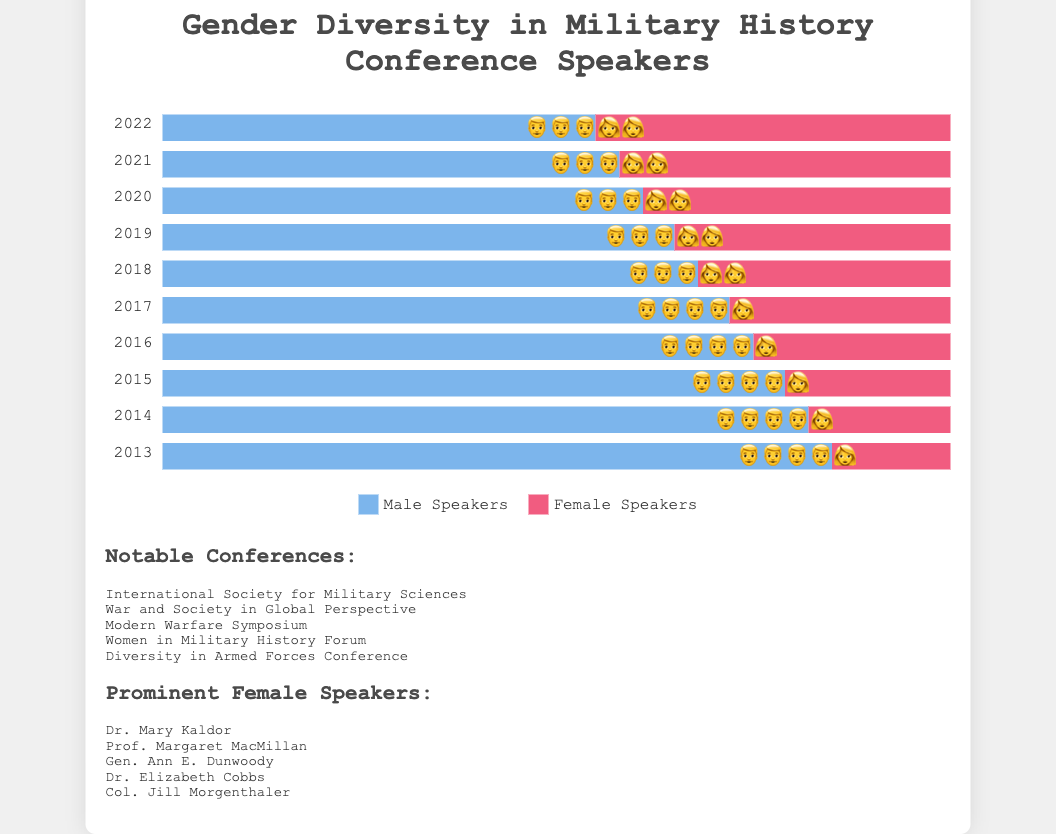What's the general trend in the number of male speakers over the past decade? By examining the bars for male speakers from 2013 to 2022, it's clear that the length of the bars decreases over time, indicating a downward trend. Thus, the number of male speakers has been consistently reducing each year.
Answer: Decreasing trend Which year had the highest percentage of female speakers? By comparing the female speaker bars for each year, 2022 shows the longest bar for female speakers, indicating it had the highest percentage.
Answer: 2022 What is the difference in the number of female speakers between 2013 and 2022? Female speakers in 2022 are 45; in 2013, they are 15. The difference is 45 - 15 = 30.
Answer: 30 Identify the year where male and female speaker percentages are closest. By visually comparing the lengths of both bars year by year, 2022 shows the most similar lengths for male (55%) and female (45%) speakers, indicating the closest percentage.
Answer: 2022 Between which consecutive years was the largest increase in female speakers observed? Observing the increase year by year, the jump from 28% in 2017 to 32% in 2018 (a 4% increase) is the largest.
Answer: Between 2017 and 2018 What percentage of speakers were male in 2015? The bar for male speakers in 2015 occupies 79% of the space, indicating 79% of the speakers were male.
Answer: 79% Compare the number of female speakers in 2016 and 2019. Which year had more female speakers? In 2016, female speakers occupied 25% of the bar, while in 2019, they occupied 35%. Therefore, 2019 had more female speakers.
Answer: 2019 If we combine male and female speakers, what is the total number of conference speakers in 2020? Male speakers: 61, Female speakers: 39, Total = 61 + 39 = 100.
Answer: 100 Calculate the average number of female speakers from the last three years (2020-2022). 2022: 45, 2021: 42, 2020: 39. The sum is 45 + 42 + 39 = 126. The average is 126 / 3 = 42.
Answer: 42 